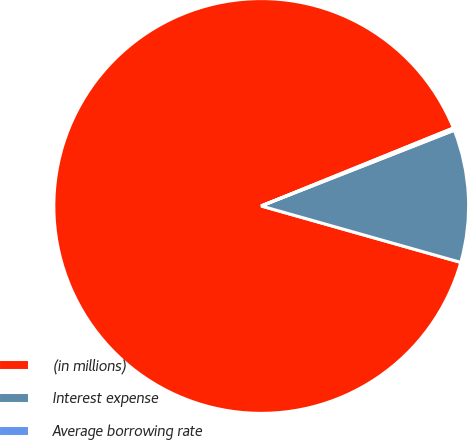Convert chart to OTSL. <chart><loc_0><loc_0><loc_500><loc_500><pie_chart><fcel>(in millions)<fcel>Interest expense<fcel>Average borrowing rate<nl><fcel>89.48%<fcel>10.34%<fcel>0.18%<nl></chart> 